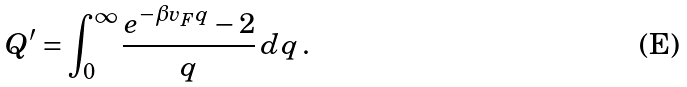<formula> <loc_0><loc_0><loc_500><loc_500>Q ^ { \prime } = \int _ { 0 } ^ { \infty } \frac { e ^ { - \beta v _ { F } q } - 2 } { q } \, d q \, .</formula> 